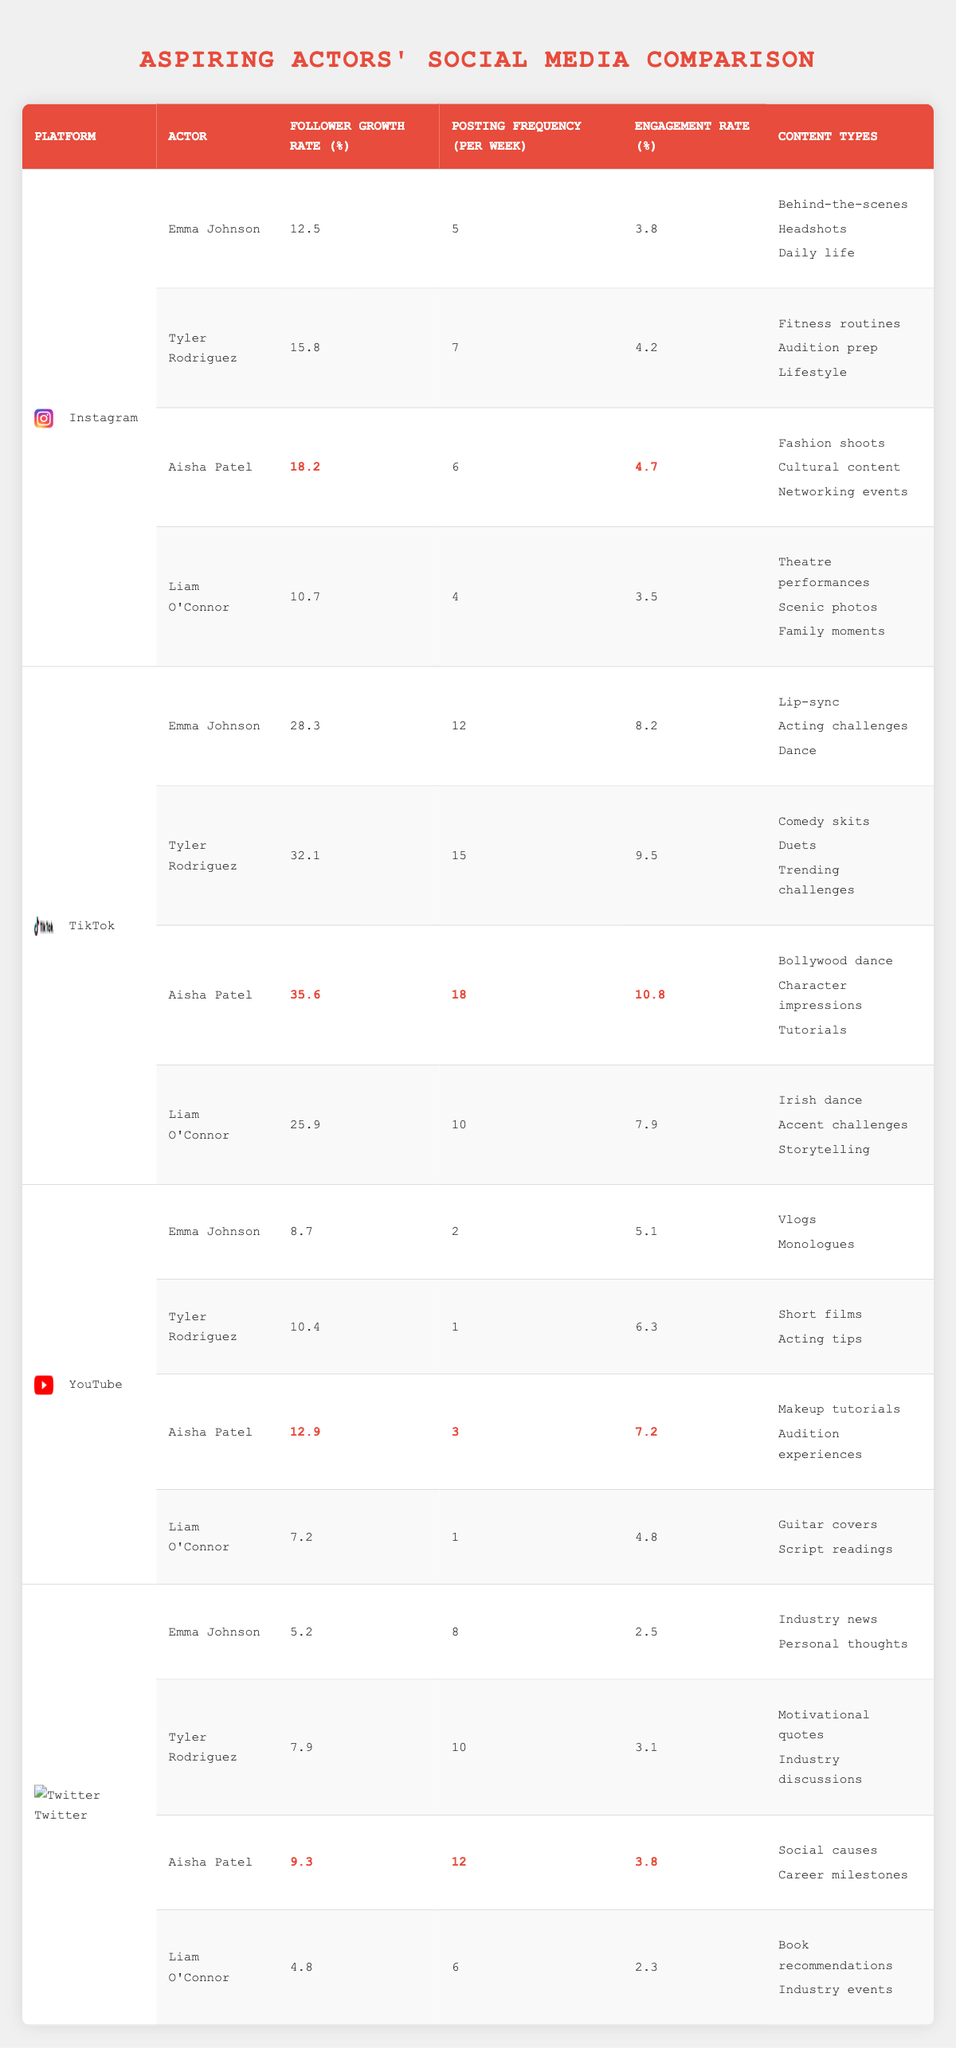What is the highest follower growth rate on Instagram? Looking at the Instagram section of the table, Aisha Patel has the highest follower growth rate of 18.2%.
Answer: 18.2 Who has the lowest engagement rate on Twitter? In the Twitter section, Liam O'Connor has the lowest engagement rate at 2.3%.
Answer: 2.3 Calculate the average posting frequency across all platforms for Tyler Rodriguez. Tyler Rodriguez posts 7 times on Instagram, 15 times on TikTok, 1 time on YouTube, and 10 times on Twitter. The total is 7 + 15 + 1 + 10 = 33. Since there are 4 platforms, the average posting frequency is 33 / 4 = 8.25.
Answer: 8.25 Does Aisha Patel have a higher follower growth rate on TikTok compared to Liam O'Connor? Aisha Patel's follower growth rate on TikTok is 35.6%, while Liam O'Connor's is 25.9%. Thus, Aisha Patel has a higher follower growth rate on TikTok.
Answer: Yes What is the difference in follower growth rate between Emma Johnson and Tyler Rodriguez on YouTube? For YouTube, Emma Johnson has a growth rate of 8.7% and Tyler Rodriguez has 10.4%. The difference is 10.4 - 8.7 = 1.7%.
Answer: 1.7 Which aspiring actor has the highest engagement rate across all platforms? By comparing the engagement rates for all four actors across the platforms, Aisha Patel has the highest engagement rate of 10.8% on TikTok.
Answer: 10.8 Are the content types for Liam O'Connor consistent across all platforms? By reviewing the content types listed for Liam O'Connor, they vary between platforms (Theatre performances, Irish dance, Guitar covers, Book recommendations), indicating inconsistency.
Answer: No What is the total follower growth rate for Emma Johnson across all platforms? For Emma Johnson, her follower growth rates are 12.5% (Instagram) + 28.3% (TikTok) + 8.7% (YouTube) + 5.2% (Twitter). Therefore, the total is 12.5 + 28.3 + 8.7 + 5.2 = 54.7%.
Answer: 54.7 Which platform has the highest average engagement rate across all aspiring actors? By calculating the engagement rates for each platform (Instagram avg = 4.03, TikTok avg = 8.1, YouTube avg = 5.8, Twitter avg = 2.93), TikTok has the highest average engagement rate of 8.1%.
Answer: 8.1 